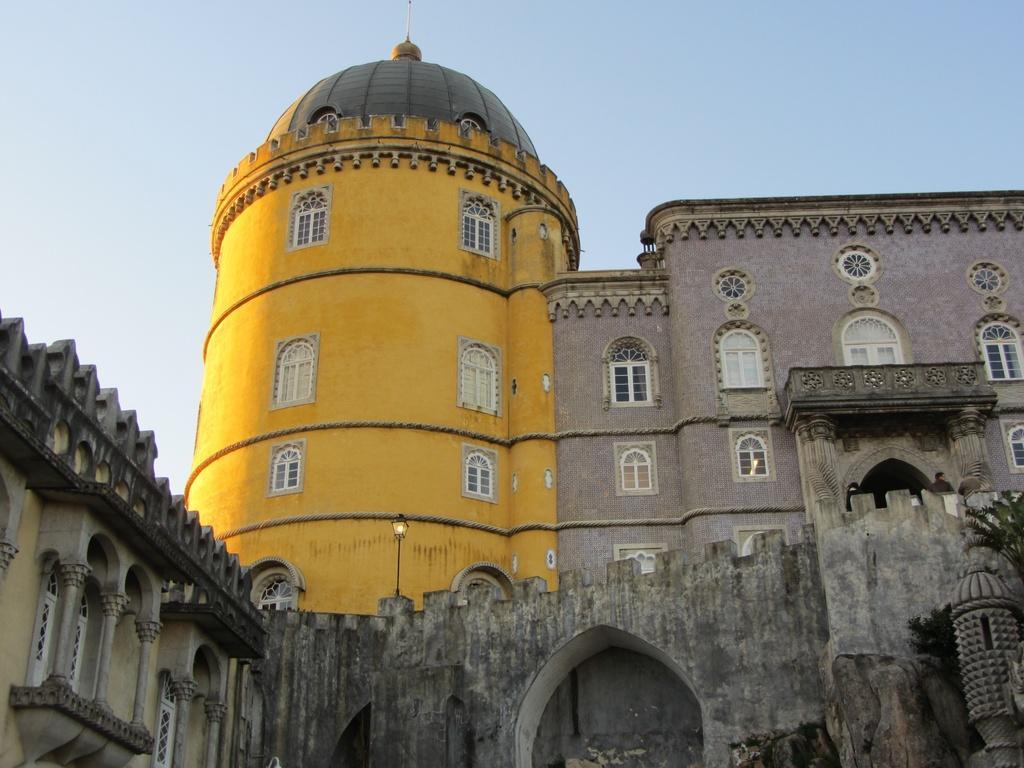Can you describe this image briefly? In this image I can see few buildings in yellow, cream and lite brown color and I can also see few windows. Background the sky is in white and blue color. 